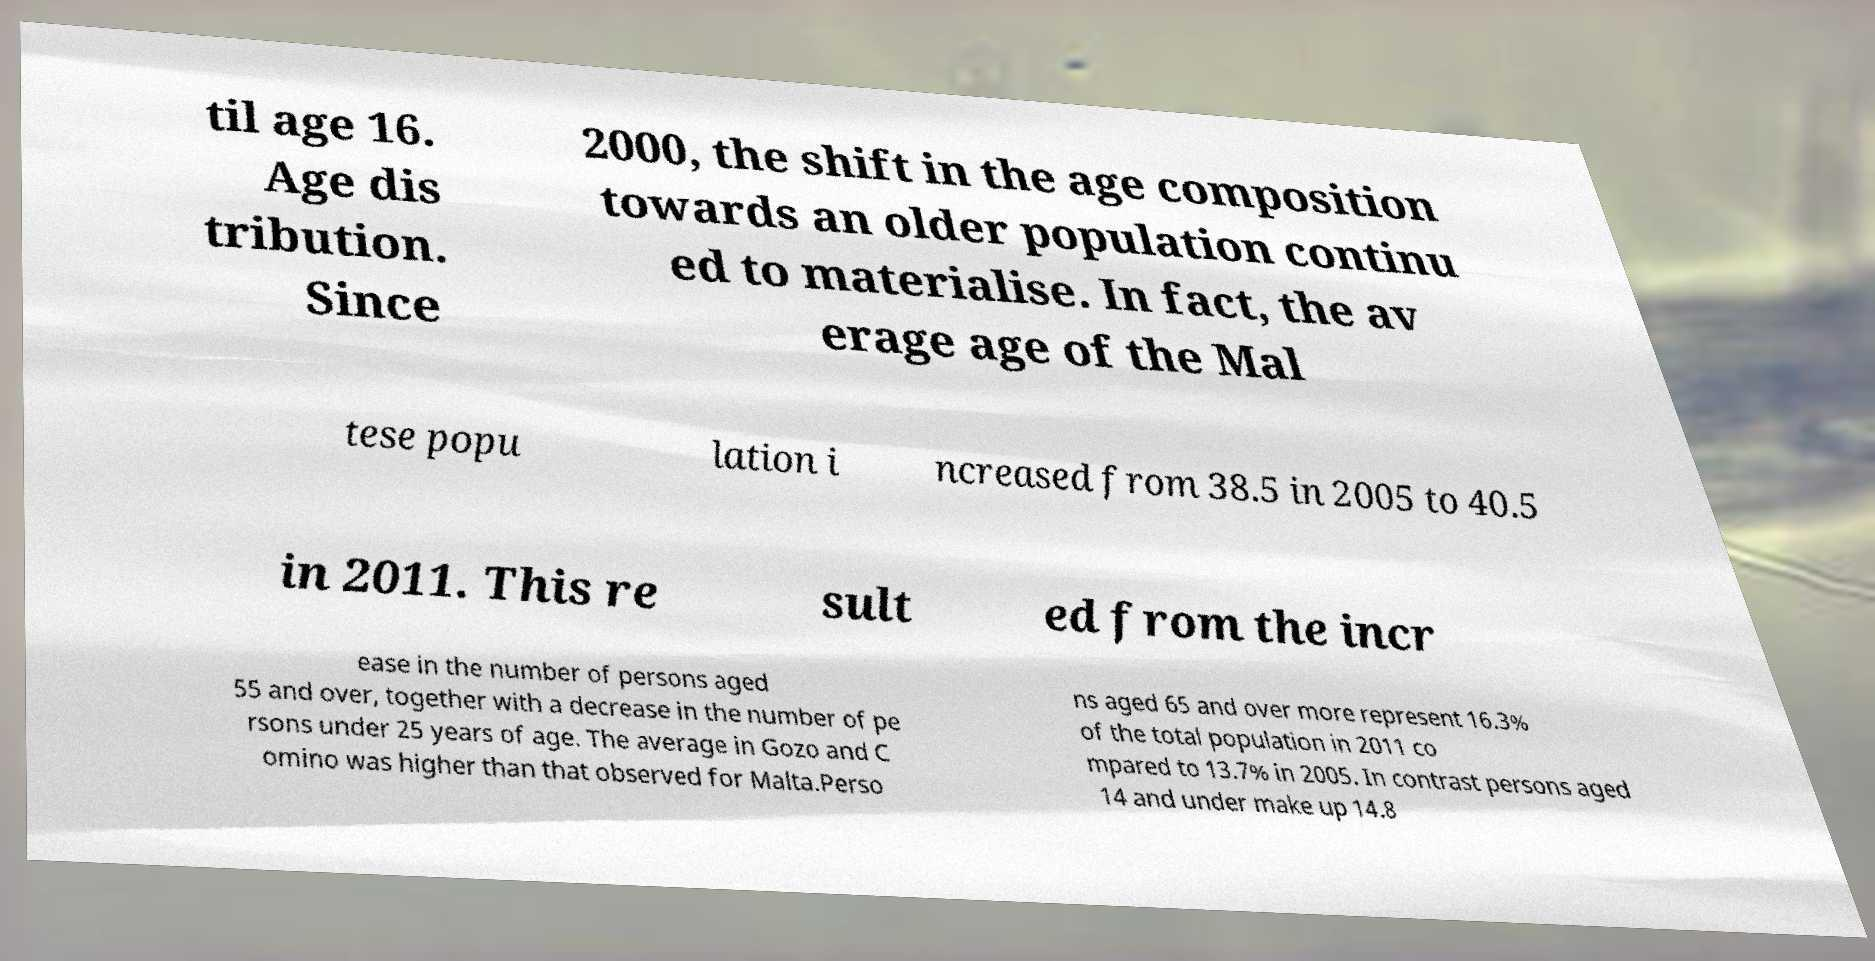Can you read and provide the text displayed in the image?This photo seems to have some interesting text. Can you extract and type it out for me? til age 16. Age dis tribution. Since 2000, the shift in the age composition towards an older population continu ed to materialise. In fact, the av erage age of the Mal tese popu lation i ncreased from 38.5 in 2005 to 40.5 in 2011. This re sult ed from the incr ease in the number of persons aged 55 and over, together with a decrease in the number of pe rsons under 25 years of age. The average in Gozo and C omino was higher than that observed for Malta.Perso ns aged 65 and over more represent 16.3% of the total population in 2011 co mpared to 13.7% in 2005. In contrast persons aged 14 and under make up 14.8 